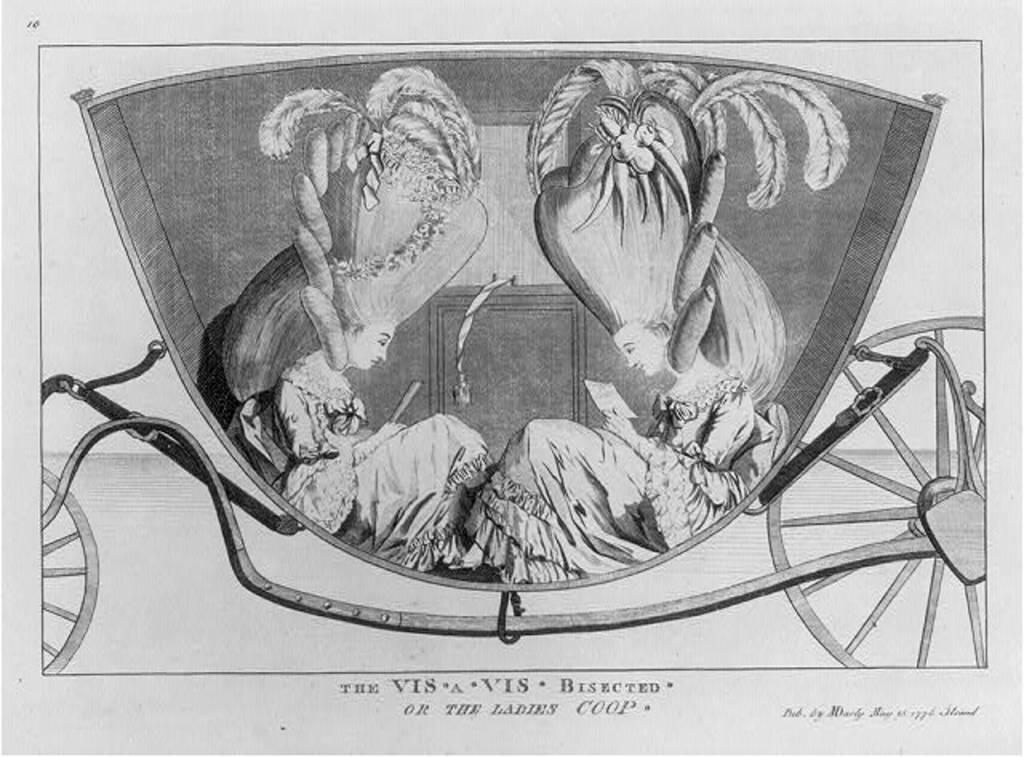What is the main subject of the image? There is a painting in the image. What is happening in the painting? The painting depicts two women sitting in a two-wheeler. Is there any text associated with the painting? Yes, there is text at the bottom of the picture. How many pizzas are being delivered by the ship in the image? There is no ship or pizzas present in the image; it features a painting of two women sitting in a two-wheeler with text at the bottom. 